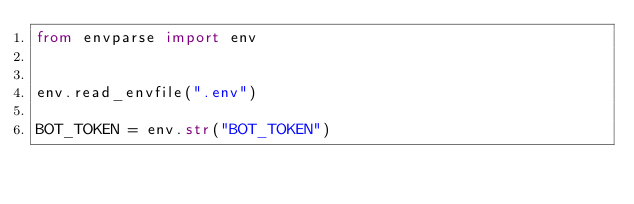Convert code to text. <code><loc_0><loc_0><loc_500><loc_500><_Python_>from envparse import env


env.read_envfile(".env")

BOT_TOKEN = env.str("BOT_TOKEN")</code> 